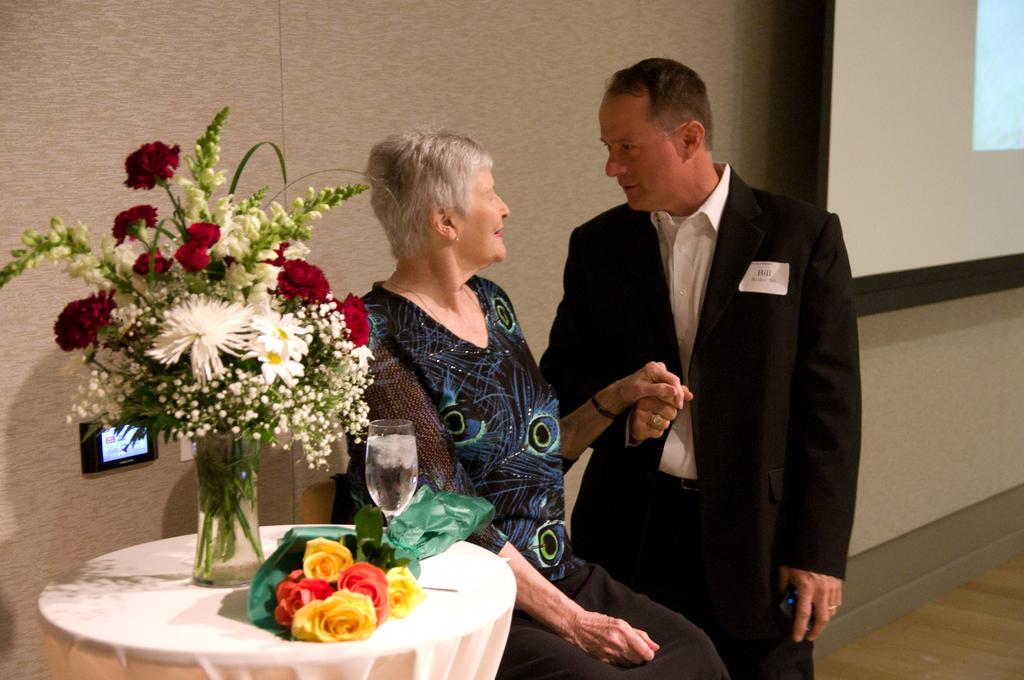How many people are in the image? There are two persons in the image. What can be seen on a table in the image? There are objects on a table in the image. What is visible on the wall in the image? A screen is attached to the wall in the image. How many grains of sand can be seen on the persons in the image? There is no sand present in the image, so it is not possible to determine the number of grains of sand on the persons. 